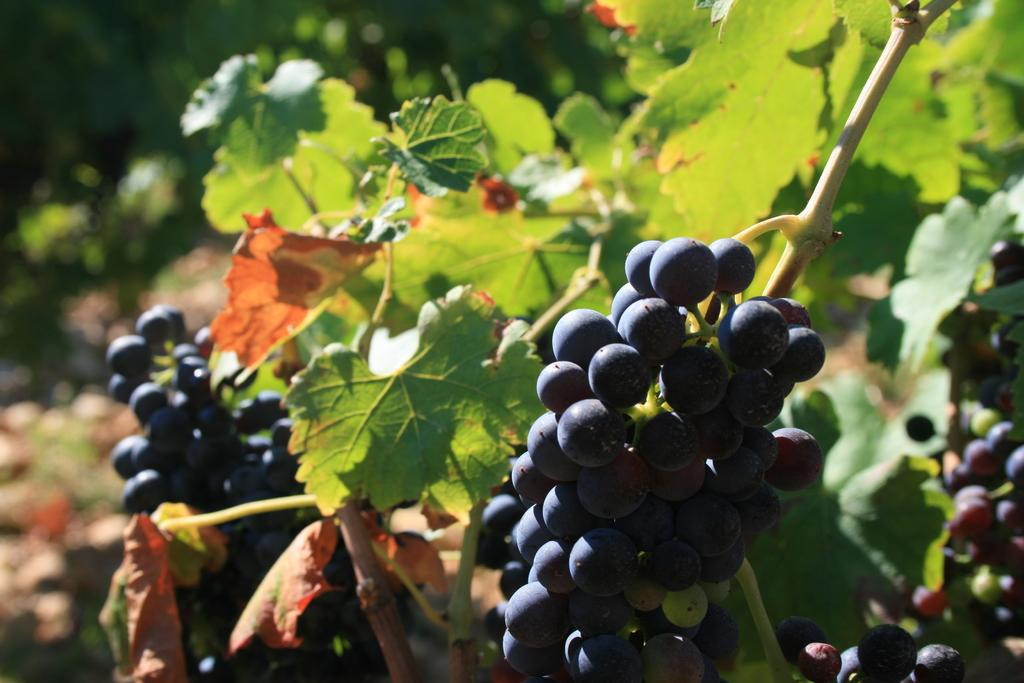What type of berries can be seen in the image? There are black colored berries in the image. What other elements are present in the image besides the berries? There are green leafs in the image. How would you describe the overall clarity of the image? The image is blurry in the background. How many jellyfish are swimming in the image? There are no jellyfish present in the image; it features black colored berries and green leafs. What year is the image from? The provided facts do not mention the year the image was taken, so it cannot be determined from the information given. 